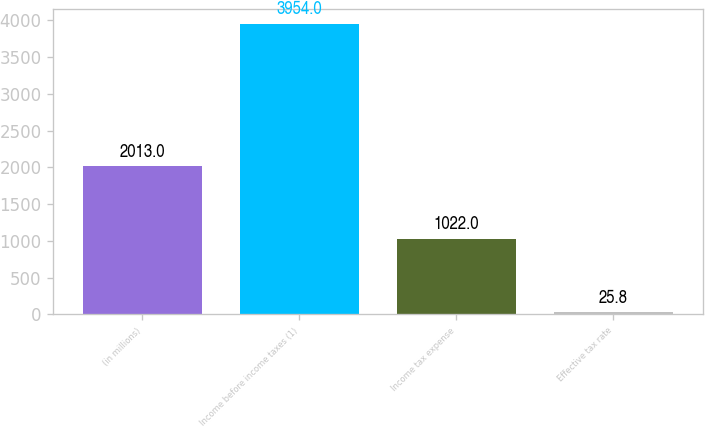Convert chart to OTSL. <chart><loc_0><loc_0><loc_500><loc_500><bar_chart><fcel>(in millions)<fcel>Income before income taxes (1)<fcel>Income tax expense<fcel>Effective tax rate<nl><fcel>2013<fcel>3954<fcel>1022<fcel>25.8<nl></chart> 